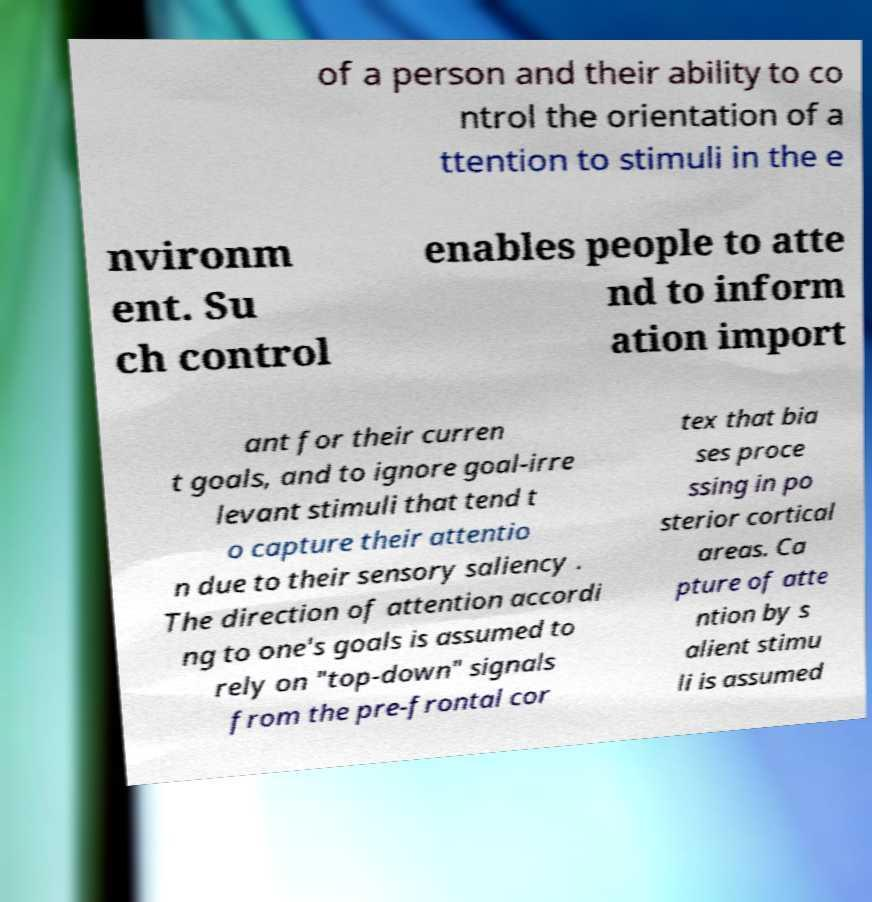For documentation purposes, I need the text within this image transcribed. Could you provide that? of a person and their ability to co ntrol the orientation of a ttention to stimuli in the e nvironm ent. Su ch control enables people to atte nd to inform ation import ant for their curren t goals, and to ignore goal-irre levant stimuli that tend t o capture their attentio n due to their sensory saliency . The direction of attention accordi ng to one's goals is assumed to rely on "top-down" signals from the pre-frontal cor tex that bia ses proce ssing in po sterior cortical areas. Ca pture of atte ntion by s alient stimu li is assumed 